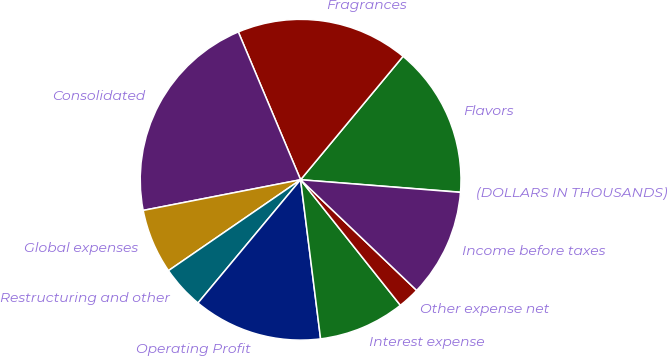Convert chart to OTSL. <chart><loc_0><loc_0><loc_500><loc_500><pie_chart><fcel>(DOLLARS IN THOUSANDS)<fcel>Flavors<fcel>Fragrances<fcel>Consolidated<fcel>Global expenses<fcel>Restructuring and other<fcel>Operating Profit<fcel>Interest expense<fcel>Other expense net<fcel>Income before taxes<nl><fcel>0.02%<fcel>15.21%<fcel>17.38%<fcel>21.72%<fcel>6.53%<fcel>4.36%<fcel>13.04%<fcel>8.7%<fcel>2.19%<fcel>10.87%<nl></chart> 